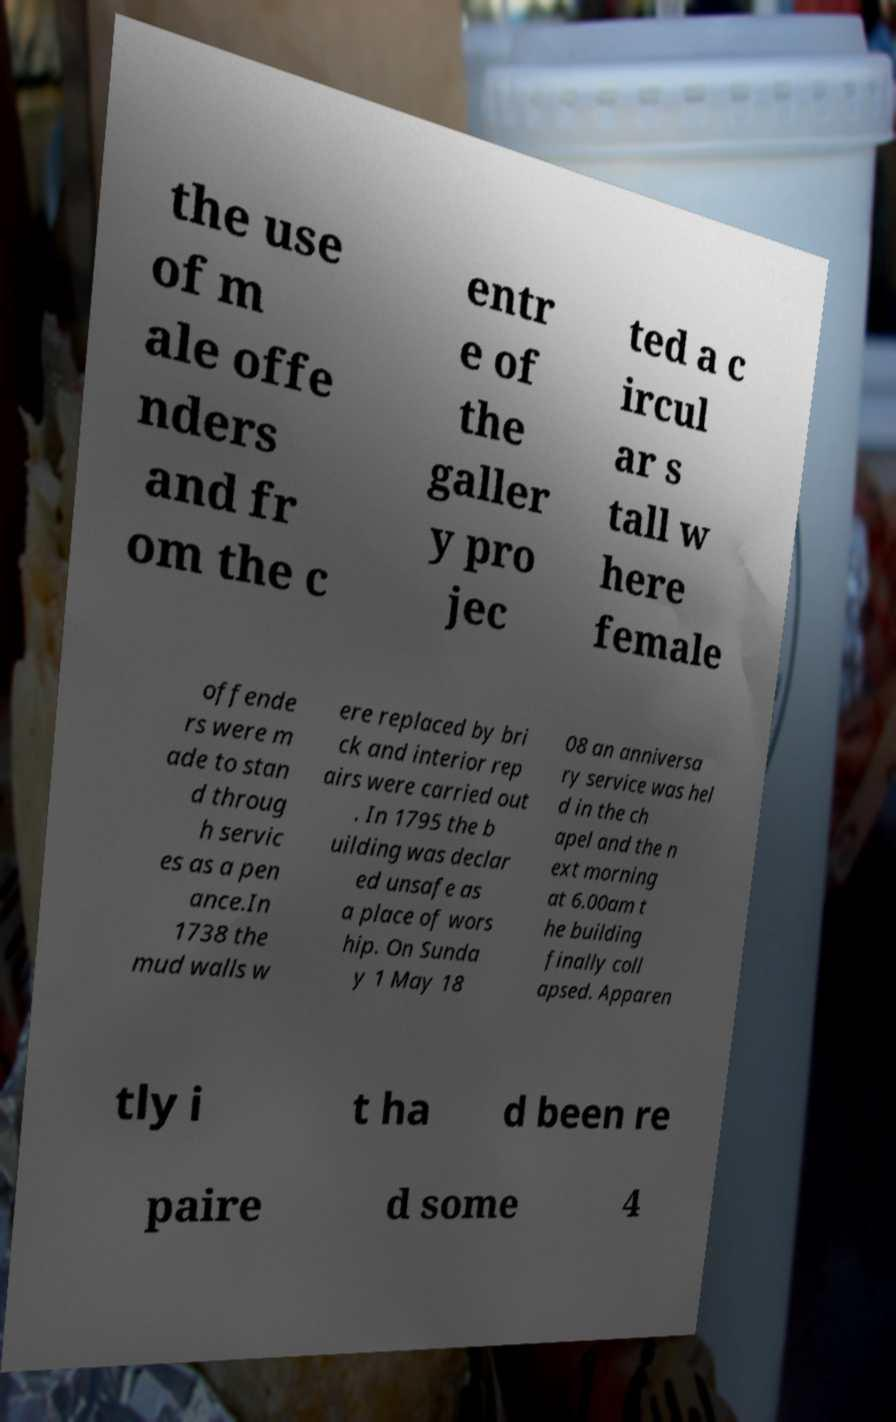Please read and relay the text visible in this image. What does it say? the use of m ale offe nders and fr om the c entr e of the galler y pro jec ted a c ircul ar s tall w here female offende rs were m ade to stan d throug h servic es as a pen ance.In 1738 the mud walls w ere replaced by bri ck and interior rep airs were carried out . In 1795 the b uilding was declar ed unsafe as a place of wors hip. On Sunda y 1 May 18 08 an anniversa ry service was hel d in the ch apel and the n ext morning at 6.00am t he building finally coll apsed. Apparen tly i t ha d been re paire d some 4 